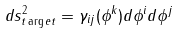<formula> <loc_0><loc_0><loc_500><loc_500>d s _ { t \arg e t } ^ { 2 } = \gamma _ { i j } ( \phi ^ { k } ) d \phi ^ { i } d \phi ^ { j }</formula> 